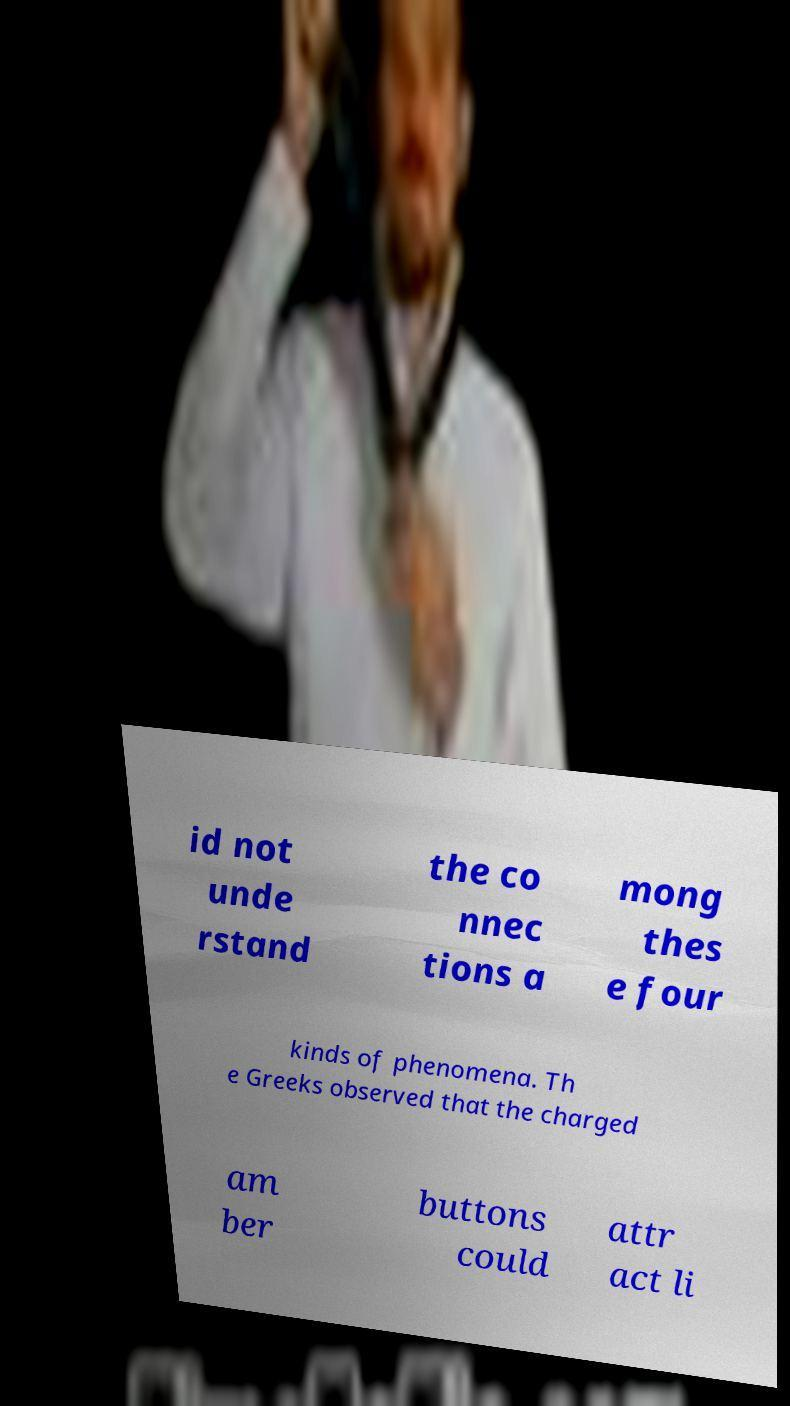For documentation purposes, I need the text within this image transcribed. Could you provide that? id not unde rstand the co nnec tions a mong thes e four kinds of phenomena. Th e Greeks observed that the charged am ber buttons could attr act li 